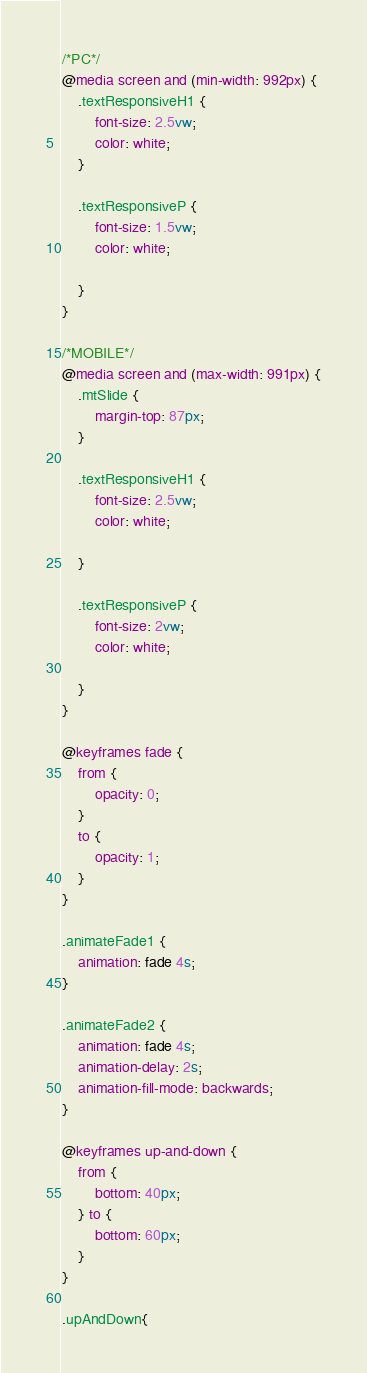<code> <loc_0><loc_0><loc_500><loc_500><_CSS_>/*PC*/
@media screen and (min-width: 992px) {
	.textResponsiveH1 {
		font-size: 2.5vw;
		color: white;
	}

	.textResponsiveP {
		font-size: 1.5vw;
		color: white;

	}
}

/*MOBILE*/
@media screen and (max-width: 991px) {
	.mtSlide {
		margin-top: 87px;
	}

	.textResponsiveH1 {
		font-size: 2.5vw;
		color: white;

	}

	.textResponsiveP {
		font-size: 2vw;
		color: white;

	}
}

@keyframes fade {
	from {
		opacity: 0;
	}
	to {
		opacity: 1;
	}
}

.animateFade1 {
	animation: fade 4s;
}

.animateFade2 {
	animation: fade 4s;
	animation-delay: 2s;
	animation-fill-mode: backwards;
}

@keyframes up-and-down {
	from {
		bottom: 40px;
	} to {
		bottom: 60px;
	}
}

.upAndDown{</code> 